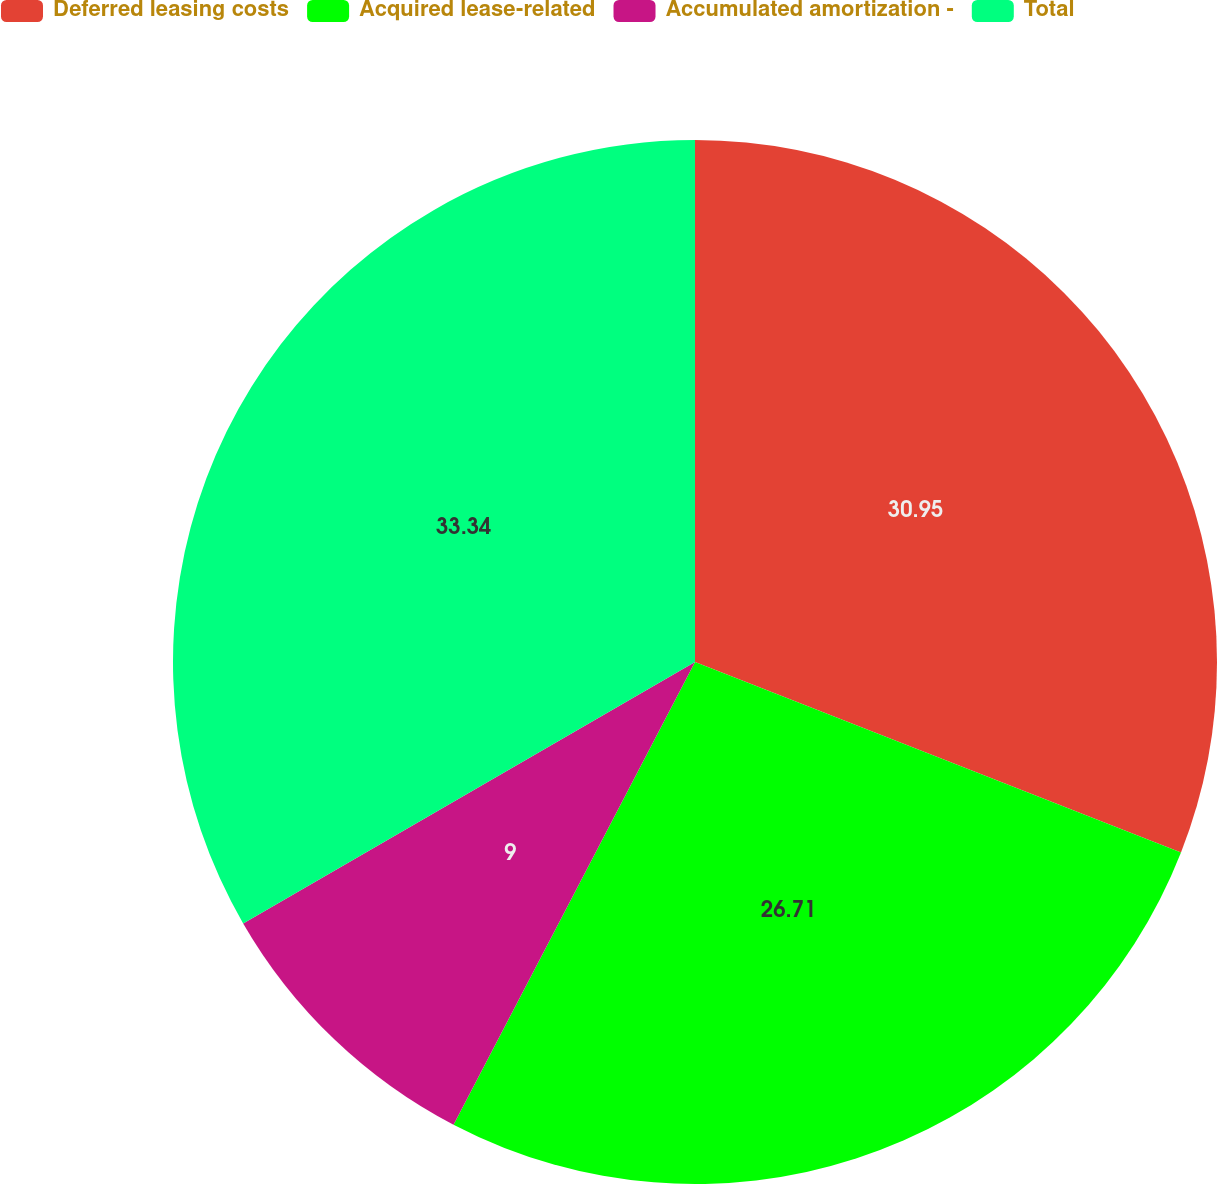<chart> <loc_0><loc_0><loc_500><loc_500><pie_chart><fcel>Deferred leasing costs<fcel>Acquired lease-related<fcel>Accumulated amortization -<fcel>Total<nl><fcel>30.95%<fcel>26.71%<fcel>9.0%<fcel>33.35%<nl></chart> 